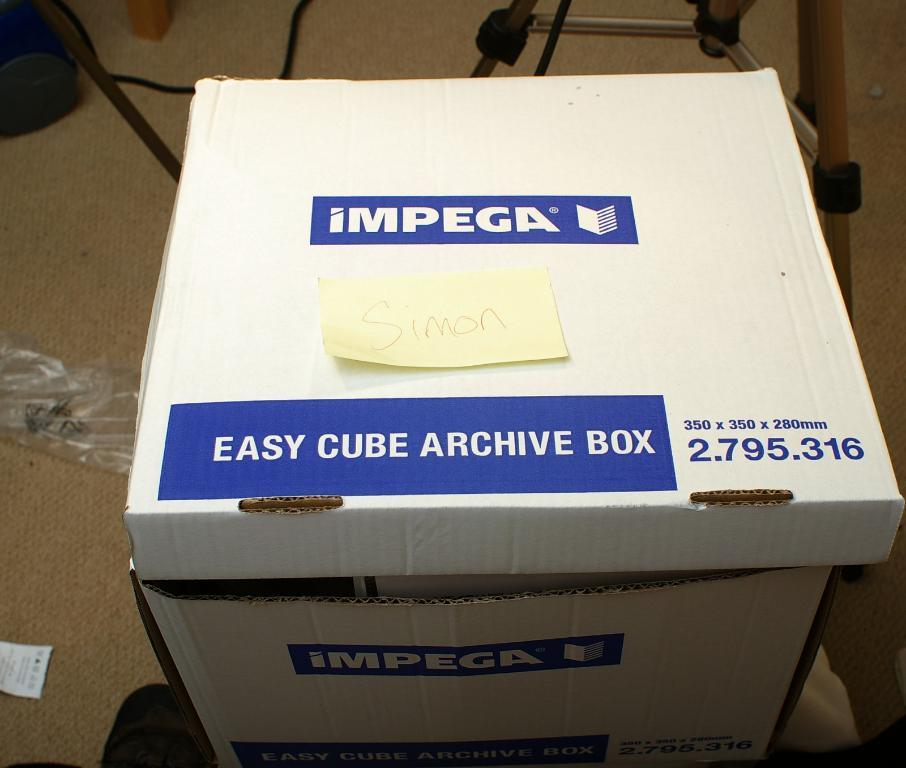<image>
Share a concise interpretation of the image provided. A white and blue cardbox with the company name IMPEGA on it for Archive Files. 